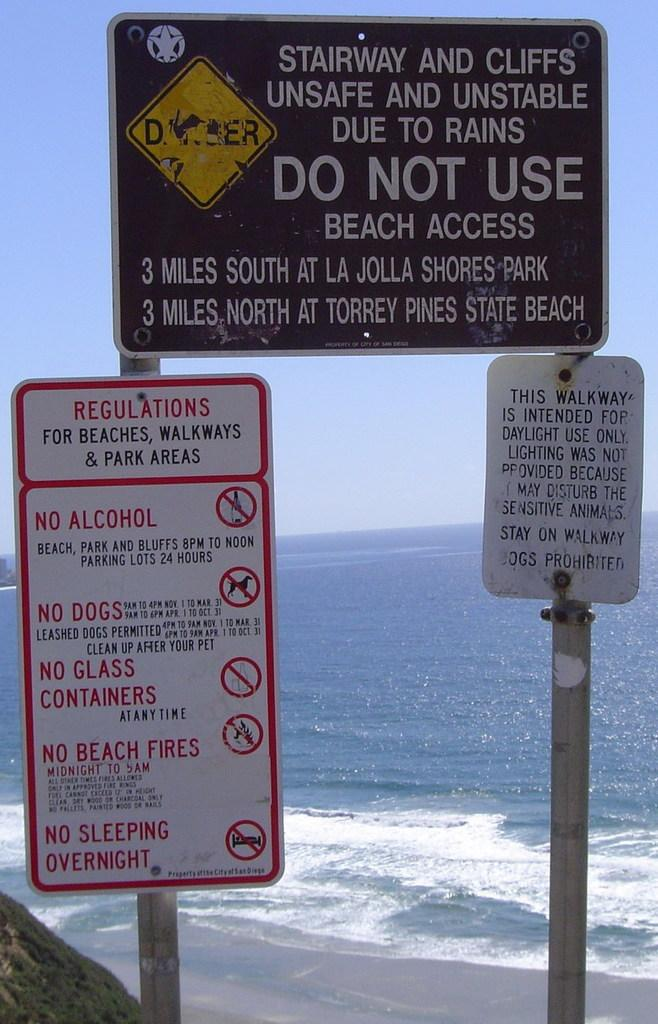<image>
Summarize the visual content of the image. A sign in front of a beach informs of unsafe cliffs and stairway. 